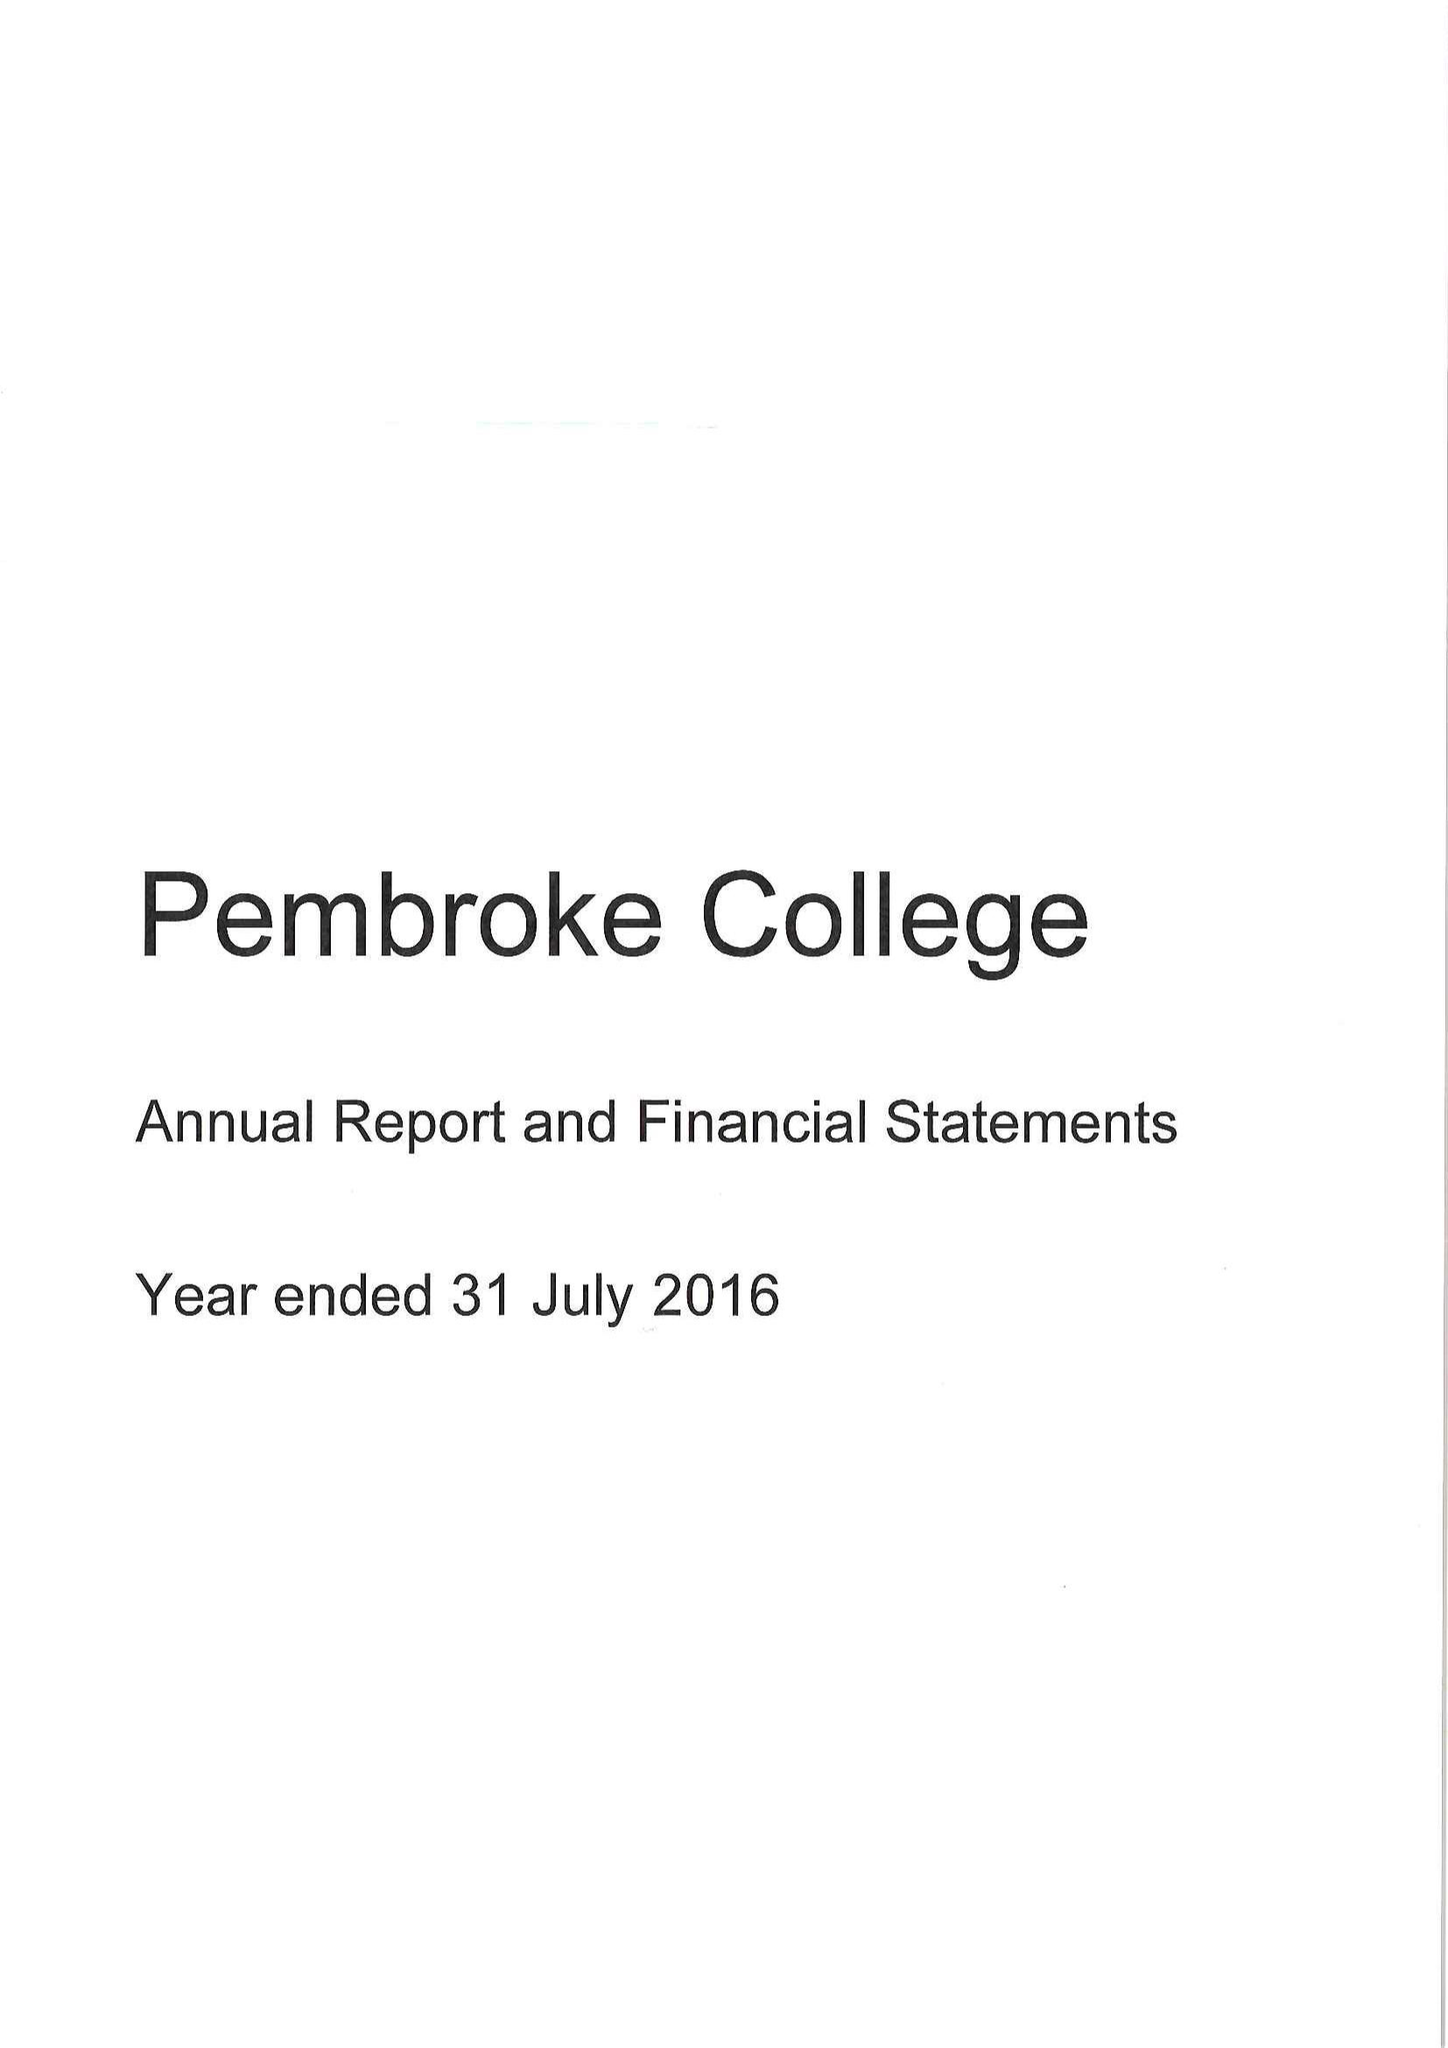What is the value for the address__street_line?
Answer the question using a single word or phrase. ST ALDATES 